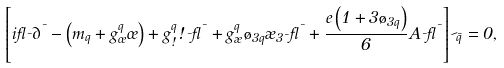Convert formula to latex. <formula><loc_0><loc_0><loc_500><loc_500>\left [ i \gamma _ { \mu } \partial ^ { \mu } - \left ( m _ { q } + g _ { \sigma } ^ { q } \sigma \right ) + g _ { \omega } ^ { q } \omega _ { \mu } \gamma ^ { \mu } + g _ { \rho } ^ { q } \tau _ { 3 q } \rho _ { 3 \mu } \gamma ^ { \mu } + \frac { e \left ( 1 + 3 \tau _ { 3 q } \right ) } { 6 } A _ { \mu } \gamma ^ { \mu } \right ] \psi _ { \bar { q } } = 0 ,</formula> 